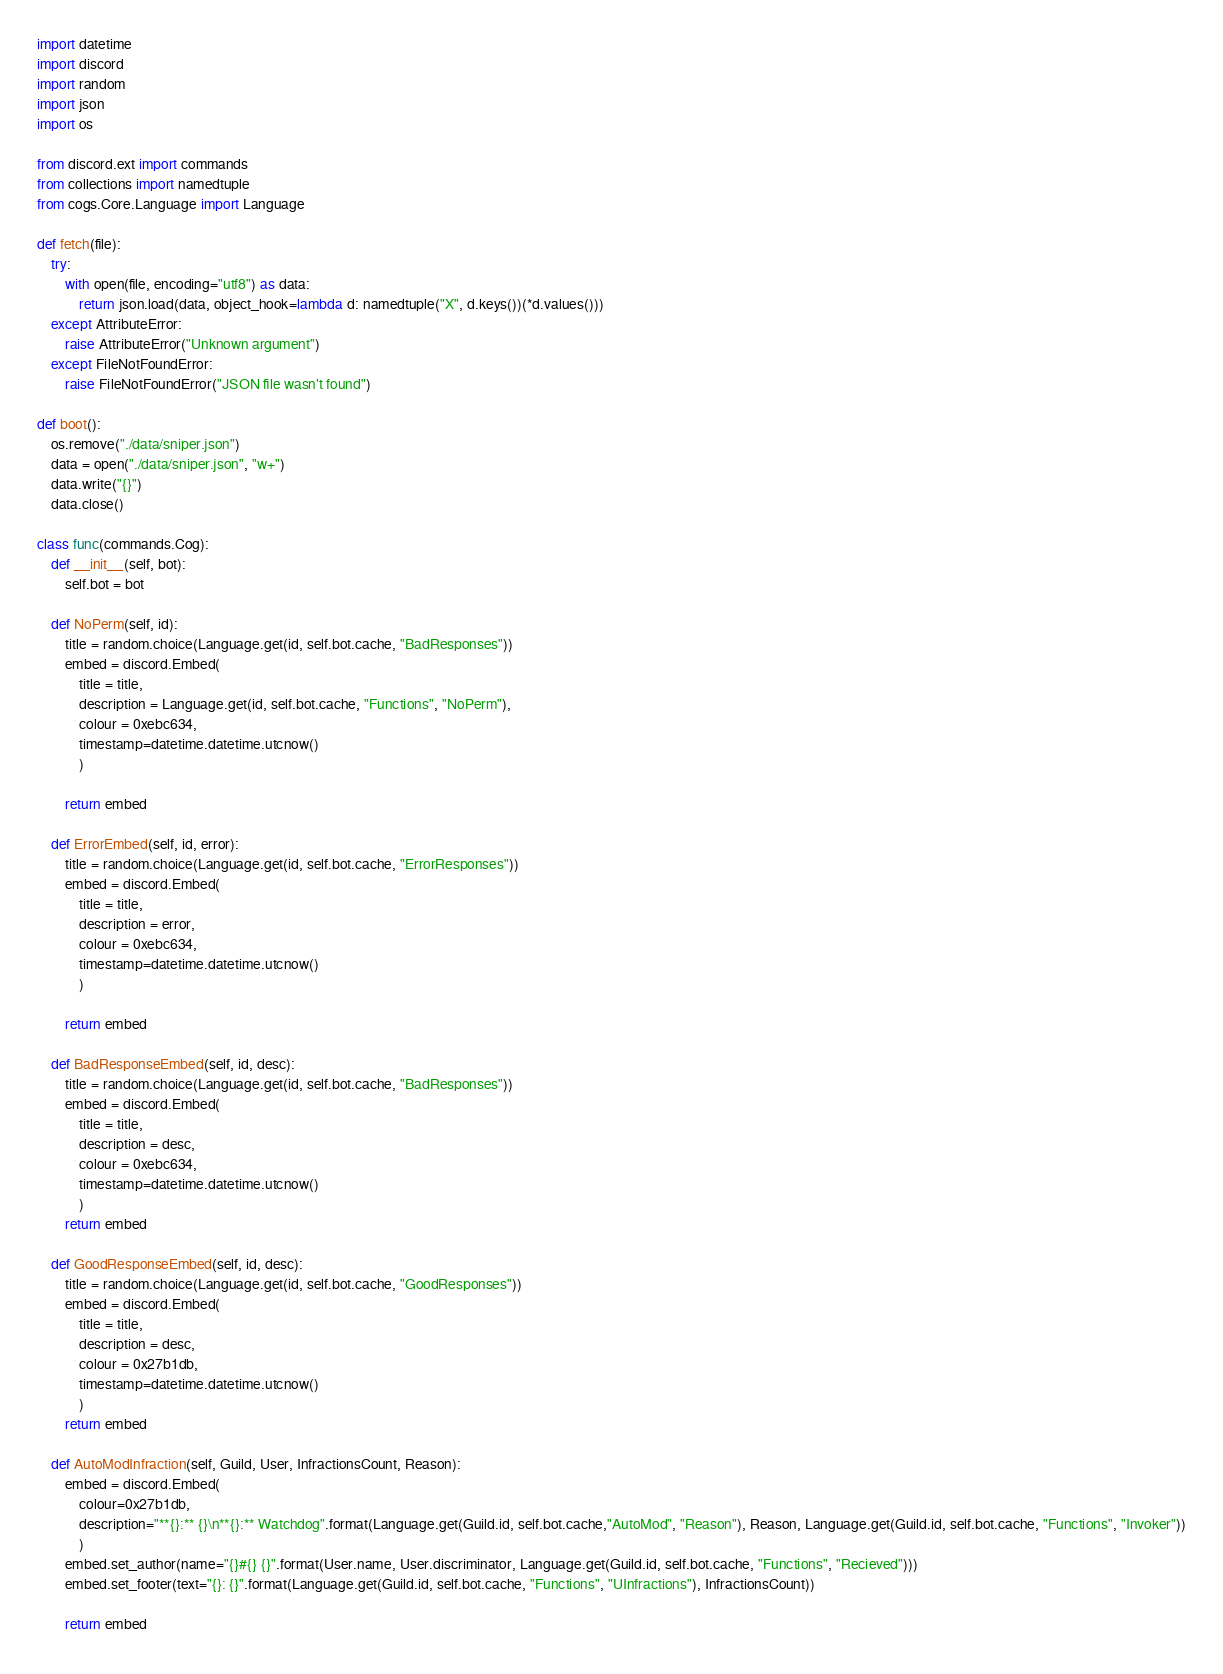<code> <loc_0><loc_0><loc_500><loc_500><_Python_>import datetime
import discord
import random
import json
import os

from discord.ext import commands
from collections import namedtuple
from cogs.Core.Language import Language

def fetch(file):
    try:
        with open(file, encoding="utf8") as data:
            return json.load(data, object_hook=lambda d: namedtuple("X", d.keys())(*d.values()))
    except AttributeError:
        raise AttributeError("Unknown argument")
    except FileNotFoundError:
        raise FileNotFoundError("JSON file wasn't found")

def boot():
    os.remove("./data/sniper.json")
    data = open("./data/sniper.json", "w+")
    data.write("{}")
    data.close()

class func(commands.Cog):
    def __init__(self, bot):
        self.bot = bot

    def NoPerm(self, id):
        title = random.choice(Language.get(id, self.bot.cache, "BadResponses"))
        embed = discord.Embed(
            title = title,
            description = Language.get(id, self.bot.cache, "Functions", "NoPerm"),
            colour = 0xebc634,
            timestamp=datetime.datetime.utcnow()
            )

        return embed

    def ErrorEmbed(self, id, error):
        title = random.choice(Language.get(id, self.bot.cache, "ErrorResponses"))
        embed = discord.Embed(
            title = title,
            description = error,
            colour = 0xebc634,
            timestamp=datetime.datetime.utcnow()
            )

        return embed

    def BadResponseEmbed(self, id, desc):
        title = random.choice(Language.get(id, self.bot.cache, "BadResponses"))
        embed = discord.Embed(
            title = title,
            description = desc,
            colour = 0xebc634,
            timestamp=datetime.datetime.utcnow()
            )
        return embed

    def GoodResponseEmbed(self, id, desc):
        title = random.choice(Language.get(id, self.bot.cache, "GoodResponses"))
        embed = discord.Embed(
            title = title,
            description = desc,
            colour = 0x27b1db,
            timestamp=datetime.datetime.utcnow()
            )
        return embed

    def AutoModInfraction(self, Guild, User, InfractionsCount, Reason):
        embed = discord.Embed(
            colour=0x27b1db,
            description="**{}:** {}\n**{}:** Watchdog".format(Language.get(Guild.id, self.bot.cache,"AutoMod", "Reason"), Reason, Language.get(Guild.id, self.bot.cache, "Functions", "Invoker"))
            )
        embed.set_author(name="{}#{} {}".format(User.name, User.discriminator, Language.get(Guild.id, self.bot.cache, "Functions", "Recieved")))
        embed.set_footer(text="{}: {}".format(Language.get(Guild.id, self.bot.cache, "Functions", "UInfractions"), InfractionsCount))

        return embed
</code> 